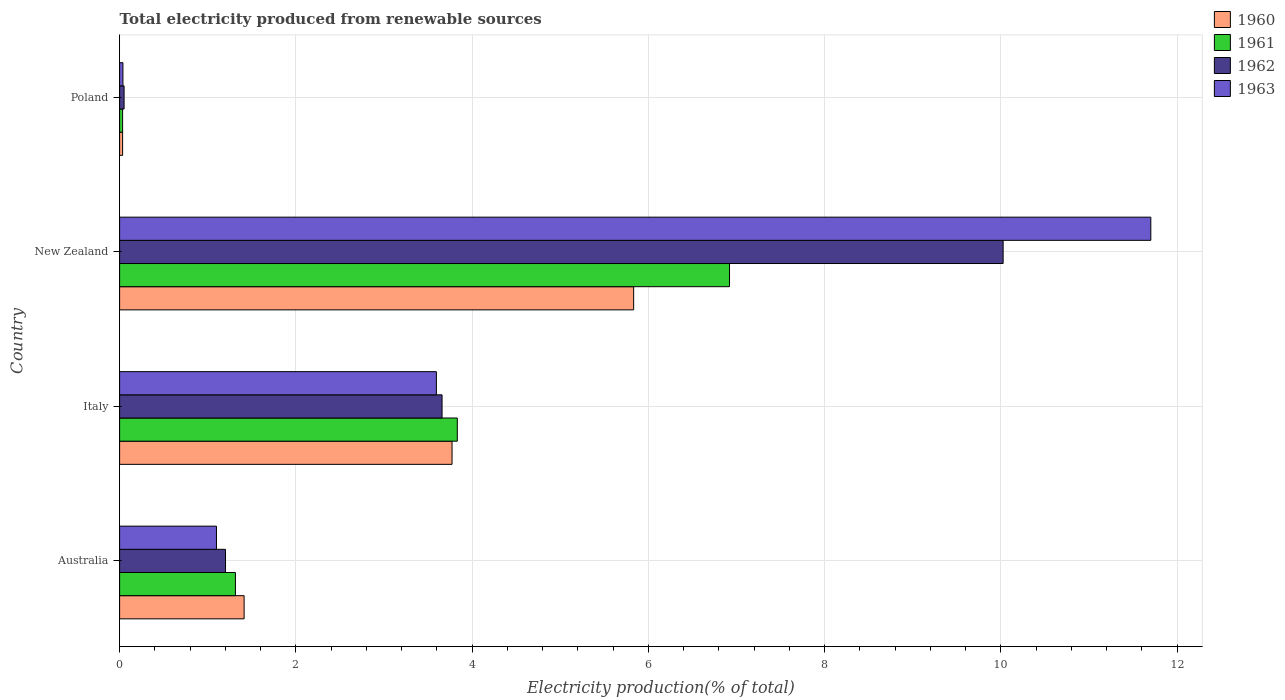How many different coloured bars are there?
Offer a very short reply. 4. Are the number of bars per tick equal to the number of legend labels?
Your answer should be very brief. Yes. How many bars are there on the 1st tick from the top?
Offer a terse response. 4. How many bars are there on the 2nd tick from the bottom?
Your answer should be compact. 4. What is the label of the 4th group of bars from the top?
Keep it short and to the point. Australia. In how many cases, is the number of bars for a given country not equal to the number of legend labels?
Give a very brief answer. 0. What is the total electricity produced in 1963 in Australia?
Keep it short and to the point. 1.1. Across all countries, what is the maximum total electricity produced in 1960?
Your answer should be compact. 5.83. Across all countries, what is the minimum total electricity produced in 1961?
Provide a succinct answer. 0.03. In which country was the total electricity produced in 1962 maximum?
Provide a succinct answer. New Zealand. In which country was the total electricity produced in 1962 minimum?
Your answer should be very brief. Poland. What is the total total electricity produced in 1963 in the graph?
Provide a short and direct response. 16.43. What is the difference between the total electricity produced in 1961 in Italy and that in Poland?
Give a very brief answer. 3.8. What is the difference between the total electricity produced in 1962 in Australia and the total electricity produced in 1963 in New Zealand?
Keep it short and to the point. -10.5. What is the average total electricity produced in 1962 per country?
Provide a succinct answer. 3.73. What is the difference between the total electricity produced in 1960 and total electricity produced in 1961 in Australia?
Your answer should be very brief. 0.1. In how many countries, is the total electricity produced in 1962 greater than 6.4 %?
Keep it short and to the point. 1. What is the ratio of the total electricity produced in 1962 in Australia to that in Italy?
Provide a succinct answer. 0.33. Is the difference between the total electricity produced in 1960 in Australia and New Zealand greater than the difference between the total electricity produced in 1961 in Australia and New Zealand?
Offer a terse response. Yes. What is the difference between the highest and the second highest total electricity produced in 1960?
Give a very brief answer. 2.06. What is the difference between the highest and the lowest total electricity produced in 1963?
Offer a very short reply. 11.66. In how many countries, is the total electricity produced in 1961 greater than the average total electricity produced in 1961 taken over all countries?
Your answer should be compact. 2. Is the sum of the total electricity produced in 1960 in Australia and New Zealand greater than the maximum total electricity produced in 1963 across all countries?
Offer a terse response. No. Is it the case that in every country, the sum of the total electricity produced in 1960 and total electricity produced in 1963 is greater than the total electricity produced in 1961?
Give a very brief answer. Yes. How many countries are there in the graph?
Offer a terse response. 4. What is the difference between two consecutive major ticks on the X-axis?
Provide a succinct answer. 2. Are the values on the major ticks of X-axis written in scientific E-notation?
Keep it short and to the point. No. Does the graph contain grids?
Offer a terse response. Yes. How many legend labels are there?
Give a very brief answer. 4. What is the title of the graph?
Ensure brevity in your answer.  Total electricity produced from renewable sources. What is the label or title of the X-axis?
Ensure brevity in your answer.  Electricity production(% of total). What is the label or title of the Y-axis?
Ensure brevity in your answer.  Country. What is the Electricity production(% of total) of 1960 in Australia?
Your answer should be compact. 1.41. What is the Electricity production(% of total) in 1961 in Australia?
Keep it short and to the point. 1.31. What is the Electricity production(% of total) in 1962 in Australia?
Offer a terse response. 1.2. What is the Electricity production(% of total) of 1963 in Australia?
Your answer should be compact. 1.1. What is the Electricity production(% of total) in 1960 in Italy?
Ensure brevity in your answer.  3.77. What is the Electricity production(% of total) in 1961 in Italy?
Give a very brief answer. 3.83. What is the Electricity production(% of total) of 1962 in Italy?
Your response must be concise. 3.66. What is the Electricity production(% of total) in 1963 in Italy?
Keep it short and to the point. 3.59. What is the Electricity production(% of total) in 1960 in New Zealand?
Make the answer very short. 5.83. What is the Electricity production(% of total) of 1961 in New Zealand?
Keep it short and to the point. 6.92. What is the Electricity production(% of total) of 1962 in New Zealand?
Your response must be concise. 10.02. What is the Electricity production(% of total) of 1963 in New Zealand?
Offer a terse response. 11.7. What is the Electricity production(% of total) in 1960 in Poland?
Provide a short and direct response. 0.03. What is the Electricity production(% of total) in 1961 in Poland?
Provide a succinct answer. 0.03. What is the Electricity production(% of total) of 1962 in Poland?
Give a very brief answer. 0.05. What is the Electricity production(% of total) in 1963 in Poland?
Provide a succinct answer. 0.04. Across all countries, what is the maximum Electricity production(% of total) in 1960?
Ensure brevity in your answer.  5.83. Across all countries, what is the maximum Electricity production(% of total) in 1961?
Give a very brief answer. 6.92. Across all countries, what is the maximum Electricity production(% of total) in 1962?
Your answer should be very brief. 10.02. Across all countries, what is the maximum Electricity production(% of total) in 1963?
Your answer should be very brief. 11.7. Across all countries, what is the minimum Electricity production(% of total) in 1960?
Your answer should be very brief. 0.03. Across all countries, what is the minimum Electricity production(% of total) of 1961?
Ensure brevity in your answer.  0.03. Across all countries, what is the minimum Electricity production(% of total) in 1962?
Give a very brief answer. 0.05. Across all countries, what is the minimum Electricity production(% of total) of 1963?
Your response must be concise. 0.04. What is the total Electricity production(% of total) of 1960 in the graph?
Your answer should be compact. 11.05. What is the total Electricity production(% of total) in 1962 in the graph?
Your answer should be compact. 14.94. What is the total Electricity production(% of total) of 1963 in the graph?
Your answer should be very brief. 16.43. What is the difference between the Electricity production(% of total) of 1960 in Australia and that in Italy?
Offer a terse response. -2.36. What is the difference between the Electricity production(% of total) in 1961 in Australia and that in Italy?
Give a very brief answer. -2.52. What is the difference between the Electricity production(% of total) in 1962 in Australia and that in Italy?
Provide a short and direct response. -2.46. What is the difference between the Electricity production(% of total) in 1963 in Australia and that in Italy?
Your answer should be compact. -2.5. What is the difference between the Electricity production(% of total) of 1960 in Australia and that in New Zealand?
Provide a succinct answer. -4.42. What is the difference between the Electricity production(% of total) of 1961 in Australia and that in New Zealand?
Your answer should be compact. -5.61. What is the difference between the Electricity production(% of total) of 1962 in Australia and that in New Zealand?
Your answer should be compact. -8.82. What is the difference between the Electricity production(% of total) of 1963 in Australia and that in New Zealand?
Your response must be concise. -10.6. What is the difference between the Electricity production(% of total) in 1960 in Australia and that in Poland?
Provide a short and direct response. 1.38. What is the difference between the Electricity production(% of total) of 1961 in Australia and that in Poland?
Your response must be concise. 1.28. What is the difference between the Electricity production(% of total) in 1962 in Australia and that in Poland?
Your answer should be very brief. 1.15. What is the difference between the Electricity production(% of total) of 1963 in Australia and that in Poland?
Ensure brevity in your answer.  1.06. What is the difference between the Electricity production(% of total) of 1960 in Italy and that in New Zealand?
Provide a succinct answer. -2.06. What is the difference between the Electricity production(% of total) in 1961 in Italy and that in New Zealand?
Ensure brevity in your answer.  -3.09. What is the difference between the Electricity production(% of total) in 1962 in Italy and that in New Zealand?
Ensure brevity in your answer.  -6.37. What is the difference between the Electricity production(% of total) in 1963 in Italy and that in New Zealand?
Provide a short and direct response. -8.11. What is the difference between the Electricity production(% of total) in 1960 in Italy and that in Poland?
Keep it short and to the point. 3.74. What is the difference between the Electricity production(% of total) of 1961 in Italy and that in Poland?
Offer a very short reply. 3.8. What is the difference between the Electricity production(% of total) in 1962 in Italy and that in Poland?
Provide a succinct answer. 3.61. What is the difference between the Electricity production(% of total) of 1963 in Italy and that in Poland?
Make the answer very short. 3.56. What is the difference between the Electricity production(% of total) of 1960 in New Zealand and that in Poland?
Offer a terse response. 5.8. What is the difference between the Electricity production(% of total) in 1961 in New Zealand and that in Poland?
Provide a short and direct response. 6.89. What is the difference between the Electricity production(% of total) in 1962 in New Zealand and that in Poland?
Provide a succinct answer. 9.97. What is the difference between the Electricity production(% of total) in 1963 in New Zealand and that in Poland?
Give a very brief answer. 11.66. What is the difference between the Electricity production(% of total) in 1960 in Australia and the Electricity production(% of total) in 1961 in Italy?
Your response must be concise. -2.42. What is the difference between the Electricity production(% of total) of 1960 in Australia and the Electricity production(% of total) of 1962 in Italy?
Offer a very short reply. -2.25. What is the difference between the Electricity production(% of total) in 1960 in Australia and the Electricity production(% of total) in 1963 in Italy?
Give a very brief answer. -2.18. What is the difference between the Electricity production(% of total) of 1961 in Australia and the Electricity production(% of total) of 1962 in Italy?
Your response must be concise. -2.34. What is the difference between the Electricity production(% of total) in 1961 in Australia and the Electricity production(% of total) in 1963 in Italy?
Give a very brief answer. -2.28. What is the difference between the Electricity production(% of total) of 1962 in Australia and the Electricity production(% of total) of 1963 in Italy?
Your answer should be very brief. -2.39. What is the difference between the Electricity production(% of total) in 1960 in Australia and the Electricity production(% of total) in 1961 in New Zealand?
Ensure brevity in your answer.  -5.51. What is the difference between the Electricity production(% of total) of 1960 in Australia and the Electricity production(% of total) of 1962 in New Zealand?
Make the answer very short. -8.61. What is the difference between the Electricity production(% of total) of 1960 in Australia and the Electricity production(% of total) of 1963 in New Zealand?
Ensure brevity in your answer.  -10.29. What is the difference between the Electricity production(% of total) of 1961 in Australia and the Electricity production(% of total) of 1962 in New Zealand?
Ensure brevity in your answer.  -8.71. What is the difference between the Electricity production(% of total) of 1961 in Australia and the Electricity production(% of total) of 1963 in New Zealand?
Keep it short and to the point. -10.39. What is the difference between the Electricity production(% of total) in 1962 in Australia and the Electricity production(% of total) in 1963 in New Zealand?
Keep it short and to the point. -10.5. What is the difference between the Electricity production(% of total) of 1960 in Australia and the Electricity production(% of total) of 1961 in Poland?
Ensure brevity in your answer.  1.38. What is the difference between the Electricity production(% of total) of 1960 in Australia and the Electricity production(% of total) of 1962 in Poland?
Your answer should be compact. 1.36. What is the difference between the Electricity production(% of total) in 1960 in Australia and the Electricity production(% of total) in 1963 in Poland?
Give a very brief answer. 1.37. What is the difference between the Electricity production(% of total) in 1961 in Australia and the Electricity production(% of total) in 1962 in Poland?
Your response must be concise. 1.26. What is the difference between the Electricity production(% of total) in 1961 in Australia and the Electricity production(% of total) in 1963 in Poland?
Your answer should be compact. 1.28. What is the difference between the Electricity production(% of total) in 1962 in Australia and the Electricity production(% of total) in 1963 in Poland?
Provide a short and direct response. 1.16. What is the difference between the Electricity production(% of total) in 1960 in Italy and the Electricity production(% of total) in 1961 in New Zealand?
Give a very brief answer. -3.15. What is the difference between the Electricity production(% of total) of 1960 in Italy and the Electricity production(% of total) of 1962 in New Zealand?
Provide a short and direct response. -6.25. What is the difference between the Electricity production(% of total) in 1960 in Italy and the Electricity production(% of total) in 1963 in New Zealand?
Your answer should be very brief. -7.93. What is the difference between the Electricity production(% of total) of 1961 in Italy and the Electricity production(% of total) of 1962 in New Zealand?
Your response must be concise. -6.19. What is the difference between the Electricity production(% of total) of 1961 in Italy and the Electricity production(% of total) of 1963 in New Zealand?
Offer a very short reply. -7.87. What is the difference between the Electricity production(% of total) of 1962 in Italy and the Electricity production(% of total) of 1963 in New Zealand?
Provide a short and direct response. -8.04. What is the difference between the Electricity production(% of total) in 1960 in Italy and the Electricity production(% of total) in 1961 in Poland?
Your response must be concise. 3.74. What is the difference between the Electricity production(% of total) in 1960 in Italy and the Electricity production(% of total) in 1962 in Poland?
Offer a very short reply. 3.72. What is the difference between the Electricity production(% of total) in 1960 in Italy and the Electricity production(% of total) in 1963 in Poland?
Your answer should be compact. 3.73. What is the difference between the Electricity production(% of total) of 1961 in Italy and the Electricity production(% of total) of 1962 in Poland?
Offer a terse response. 3.78. What is the difference between the Electricity production(% of total) of 1961 in Italy and the Electricity production(% of total) of 1963 in Poland?
Ensure brevity in your answer.  3.79. What is the difference between the Electricity production(% of total) in 1962 in Italy and the Electricity production(% of total) in 1963 in Poland?
Your response must be concise. 3.62. What is the difference between the Electricity production(% of total) in 1960 in New Zealand and the Electricity production(% of total) in 1961 in Poland?
Offer a terse response. 5.8. What is the difference between the Electricity production(% of total) in 1960 in New Zealand and the Electricity production(% of total) in 1962 in Poland?
Your answer should be compact. 5.78. What is the difference between the Electricity production(% of total) in 1960 in New Zealand and the Electricity production(% of total) in 1963 in Poland?
Offer a terse response. 5.79. What is the difference between the Electricity production(% of total) in 1961 in New Zealand and the Electricity production(% of total) in 1962 in Poland?
Make the answer very short. 6.87. What is the difference between the Electricity production(% of total) in 1961 in New Zealand and the Electricity production(% of total) in 1963 in Poland?
Offer a very short reply. 6.88. What is the difference between the Electricity production(% of total) of 1962 in New Zealand and the Electricity production(% of total) of 1963 in Poland?
Provide a short and direct response. 9.99. What is the average Electricity production(% of total) in 1960 per country?
Provide a succinct answer. 2.76. What is the average Electricity production(% of total) of 1961 per country?
Your answer should be very brief. 3.02. What is the average Electricity production(% of total) in 1962 per country?
Make the answer very short. 3.73. What is the average Electricity production(% of total) of 1963 per country?
Offer a very short reply. 4.11. What is the difference between the Electricity production(% of total) of 1960 and Electricity production(% of total) of 1961 in Australia?
Offer a very short reply. 0.1. What is the difference between the Electricity production(% of total) of 1960 and Electricity production(% of total) of 1962 in Australia?
Your answer should be compact. 0.21. What is the difference between the Electricity production(% of total) of 1960 and Electricity production(% of total) of 1963 in Australia?
Ensure brevity in your answer.  0.31. What is the difference between the Electricity production(% of total) in 1961 and Electricity production(% of total) in 1962 in Australia?
Your answer should be very brief. 0.11. What is the difference between the Electricity production(% of total) of 1961 and Electricity production(% of total) of 1963 in Australia?
Give a very brief answer. 0.21. What is the difference between the Electricity production(% of total) in 1962 and Electricity production(% of total) in 1963 in Australia?
Your answer should be compact. 0.1. What is the difference between the Electricity production(% of total) in 1960 and Electricity production(% of total) in 1961 in Italy?
Offer a very short reply. -0.06. What is the difference between the Electricity production(% of total) of 1960 and Electricity production(% of total) of 1962 in Italy?
Ensure brevity in your answer.  0.11. What is the difference between the Electricity production(% of total) of 1960 and Electricity production(% of total) of 1963 in Italy?
Your answer should be compact. 0.18. What is the difference between the Electricity production(% of total) in 1961 and Electricity production(% of total) in 1962 in Italy?
Offer a terse response. 0.17. What is the difference between the Electricity production(% of total) in 1961 and Electricity production(% of total) in 1963 in Italy?
Provide a short and direct response. 0.24. What is the difference between the Electricity production(% of total) of 1962 and Electricity production(% of total) of 1963 in Italy?
Give a very brief answer. 0.06. What is the difference between the Electricity production(% of total) of 1960 and Electricity production(% of total) of 1961 in New Zealand?
Ensure brevity in your answer.  -1.09. What is the difference between the Electricity production(% of total) of 1960 and Electricity production(% of total) of 1962 in New Zealand?
Ensure brevity in your answer.  -4.19. What is the difference between the Electricity production(% of total) of 1960 and Electricity production(% of total) of 1963 in New Zealand?
Keep it short and to the point. -5.87. What is the difference between the Electricity production(% of total) of 1961 and Electricity production(% of total) of 1962 in New Zealand?
Your response must be concise. -3.1. What is the difference between the Electricity production(% of total) of 1961 and Electricity production(% of total) of 1963 in New Zealand?
Provide a succinct answer. -4.78. What is the difference between the Electricity production(% of total) in 1962 and Electricity production(% of total) in 1963 in New Zealand?
Your answer should be compact. -1.68. What is the difference between the Electricity production(% of total) of 1960 and Electricity production(% of total) of 1962 in Poland?
Your answer should be very brief. -0.02. What is the difference between the Electricity production(% of total) in 1960 and Electricity production(% of total) in 1963 in Poland?
Offer a very short reply. -0. What is the difference between the Electricity production(% of total) in 1961 and Electricity production(% of total) in 1962 in Poland?
Ensure brevity in your answer.  -0.02. What is the difference between the Electricity production(% of total) of 1961 and Electricity production(% of total) of 1963 in Poland?
Provide a succinct answer. -0. What is the difference between the Electricity production(% of total) in 1962 and Electricity production(% of total) in 1963 in Poland?
Your answer should be very brief. 0.01. What is the ratio of the Electricity production(% of total) of 1960 in Australia to that in Italy?
Your answer should be compact. 0.37. What is the ratio of the Electricity production(% of total) of 1961 in Australia to that in Italy?
Your answer should be compact. 0.34. What is the ratio of the Electricity production(% of total) of 1962 in Australia to that in Italy?
Give a very brief answer. 0.33. What is the ratio of the Electricity production(% of total) in 1963 in Australia to that in Italy?
Offer a very short reply. 0.31. What is the ratio of the Electricity production(% of total) in 1960 in Australia to that in New Zealand?
Ensure brevity in your answer.  0.24. What is the ratio of the Electricity production(% of total) of 1961 in Australia to that in New Zealand?
Keep it short and to the point. 0.19. What is the ratio of the Electricity production(% of total) of 1962 in Australia to that in New Zealand?
Your answer should be compact. 0.12. What is the ratio of the Electricity production(% of total) of 1963 in Australia to that in New Zealand?
Give a very brief answer. 0.09. What is the ratio of the Electricity production(% of total) in 1960 in Australia to that in Poland?
Offer a terse response. 41.37. What is the ratio of the Electricity production(% of total) of 1961 in Australia to that in Poland?
Give a very brief answer. 38.51. What is the ratio of the Electricity production(% of total) of 1962 in Australia to that in Poland?
Your answer should be very brief. 23.61. What is the ratio of the Electricity production(% of total) of 1963 in Australia to that in Poland?
Provide a short and direct response. 29. What is the ratio of the Electricity production(% of total) in 1960 in Italy to that in New Zealand?
Make the answer very short. 0.65. What is the ratio of the Electricity production(% of total) in 1961 in Italy to that in New Zealand?
Offer a very short reply. 0.55. What is the ratio of the Electricity production(% of total) in 1962 in Italy to that in New Zealand?
Offer a terse response. 0.36. What is the ratio of the Electricity production(% of total) in 1963 in Italy to that in New Zealand?
Provide a succinct answer. 0.31. What is the ratio of the Electricity production(% of total) of 1960 in Italy to that in Poland?
Provide a short and direct response. 110.45. What is the ratio of the Electricity production(% of total) in 1961 in Italy to that in Poland?
Your answer should be very brief. 112.3. What is the ratio of the Electricity production(% of total) of 1962 in Italy to that in Poland?
Offer a very short reply. 71.88. What is the ratio of the Electricity production(% of total) in 1963 in Italy to that in Poland?
Offer a very short reply. 94.84. What is the ratio of the Electricity production(% of total) in 1960 in New Zealand to that in Poland?
Make the answer very short. 170.79. What is the ratio of the Electricity production(% of total) of 1961 in New Zealand to that in Poland?
Keep it short and to the point. 202.83. What is the ratio of the Electricity production(% of total) of 1962 in New Zealand to that in Poland?
Provide a succinct answer. 196.95. What is the ratio of the Electricity production(% of total) of 1963 in New Zealand to that in Poland?
Your response must be concise. 308.73. What is the difference between the highest and the second highest Electricity production(% of total) of 1960?
Your answer should be compact. 2.06. What is the difference between the highest and the second highest Electricity production(% of total) in 1961?
Give a very brief answer. 3.09. What is the difference between the highest and the second highest Electricity production(% of total) of 1962?
Make the answer very short. 6.37. What is the difference between the highest and the second highest Electricity production(% of total) in 1963?
Your response must be concise. 8.11. What is the difference between the highest and the lowest Electricity production(% of total) of 1960?
Provide a short and direct response. 5.8. What is the difference between the highest and the lowest Electricity production(% of total) in 1961?
Make the answer very short. 6.89. What is the difference between the highest and the lowest Electricity production(% of total) in 1962?
Your answer should be very brief. 9.97. What is the difference between the highest and the lowest Electricity production(% of total) in 1963?
Keep it short and to the point. 11.66. 